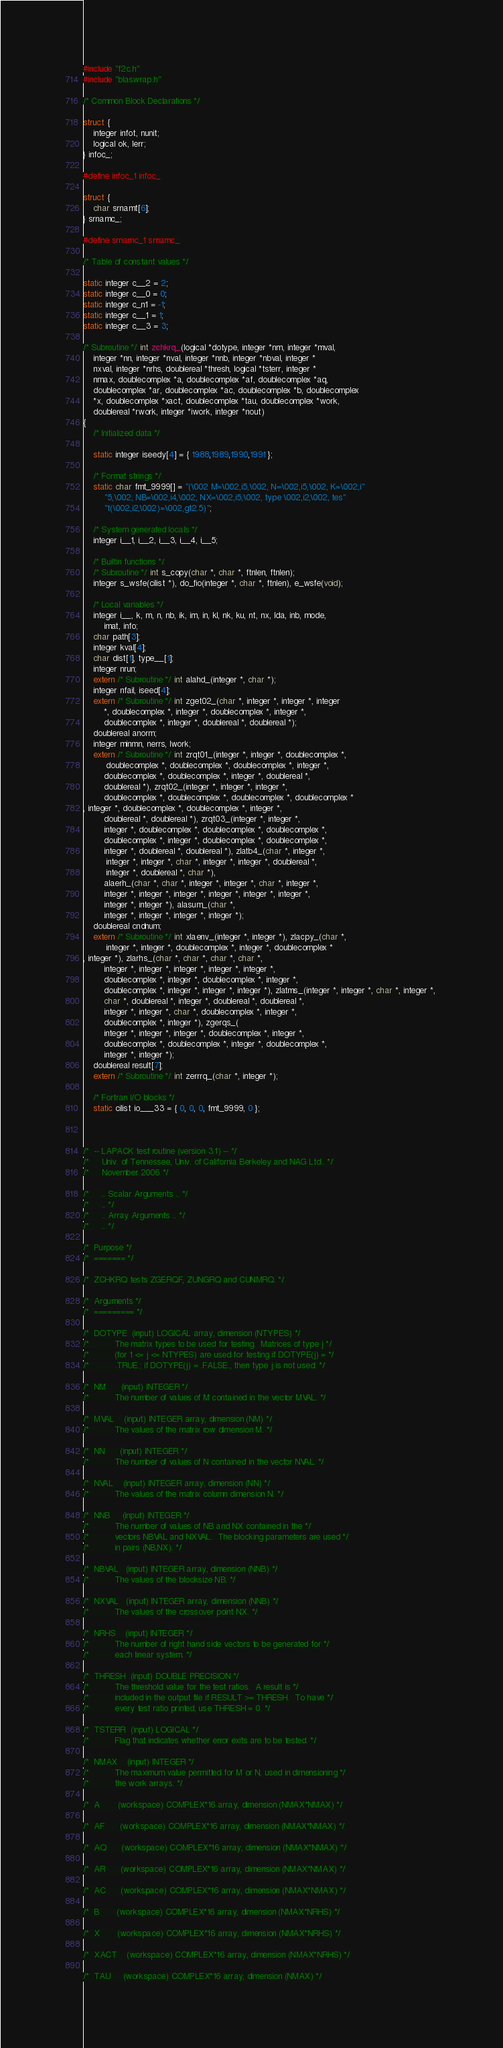Convert code to text. <code><loc_0><loc_0><loc_500><loc_500><_C_>#include "f2c.h"
#include "blaswrap.h"

/* Common Block Declarations */

struct {
    integer infot, nunit;
    logical ok, lerr;
} infoc_;

#define infoc_1 infoc_

struct {
    char srnamt[6];
} srnamc_;

#define srnamc_1 srnamc_

/* Table of constant values */

static integer c__2 = 2;
static integer c__0 = 0;
static integer c_n1 = -1;
static integer c__1 = 1;
static integer c__3 = 3;

/* Subroutine */ int zchkrq_(logical *dotype, integer *nm, integer *mval, 
	integer *nn, integer *nval, integer *nnb, integer *nbval, integer *
	nxval, integer *nrhs, doublereal *thresh, logical *tsterr, integer *
	nmax, doublecomplex *a, doublecomplex *af, doublecomplex *aq, 
	doublecomplex *ar, doublecomplex *ac, doublecomplex *b, doublecomplex 
	*x, doublecomplex *xact, doublecomplex *tau, doublecomplex *work, 
	doublereal *rwork, integer *iwork, integer *nout)
{
    /* Initialized data */

    static integer iseedy[4] = { 1988,1989,1990,1991 };

    /* Format strings */
    static char fmt_9999[] = "(\002 M=\002,i5,\002, N=\002,i5,\002, K=\002,i"
	    "5,\002, NB=\002,i4,\002, NX=\002,i5,\002, type \002,i2,\002, tes"
	    "t(\002,i2,\002)=\002,g12.5)";

    /* System generated locals */
    integer i__1, i__2, i__3, i__4, i__5;

    /* Builtin functions */
    /* Subroutine */ int s_copy(char *, char *, ftnlen, ftnlen);
    integer s_wsfe(cilist *), do_fio(integer *, char *, ftnlen), e_wsfe(void);

    /* Local variables */
    integer i__, k, m, n, nb, ik, im, in, kl, nk, ku, nt, nx, lda, inb, mode, 
	    imat, info;
    char path[3];
    integer kval[4];
    char dist[1], type__[1];
    integer nrun;
    extern /* Subroutine */ int alahd_(integer *, char *);
    integer nfail, iseed[4];
    extern /* Subroutine */ int zget02_(char *, integer *, integer *, integer 
	    *, doublecomplex *, integer *, doublecomplex *, integer *, 
	    doublecomplex *, integer *, doublereal *, doublereal *);
    doublereal anorm;
    integer minmn, nerrs, lwork;
    extern /* Subroutine */ int zrqt01_(integer *, integer *, doublecomplex *, 
	     doublecomplex *, doublecomplex *, doublecomplex *, integer *, 
	    doublecomplex *, doublecomplex *, integer *, doublereal *, 
	    doublereal *), zrqt02_(integer *, integer *, integer *, 
	    doublecomplex *, doublecomplex *, doublecomplex *, doublecomplex *
, integer *, doublecomplex *, doublecomplex *, integer *, 
	    doublereal *, doublereal *), zrqt03_(integer *, integer *, 
	    integer *, doublecomplex *, doublecomplex *, doublecomplex *, 
	    doublecomplex *, integer *, doublecomplex *, doublecomplex *, 
	    integer *, doublereal *, doublereal *), zlatb4_(char *, integer *, 
	     integer *, integer *, char *, integer *, integer *, doublereal *, 
	     integer *, doublereal *, char *), 
	    alaerh_(char *, char *, integer *, integer *, char *, integer *, 
	    integer *, integer *, integer *, integer *, integer *, integer *, 
	    integer *, integer *), alasum_(char *, 
	    integer *, integer *, integer *, integer *);
    doublereal cndnum;
    extern /* Subroutine */ int xlaenv_(integer *, integer *), zlacpy_(char *, 
	     integer *, integer *, doublecomplex *, integer *, doublecomplex *
, integer *), zlarhs_(char *, char *, char *, char *, 
	    integer *, integer *, integer *, integer *, integer *, 
	    doublecomplex *, integer *, doublecomplex *, integer *, 
	    doublecomplex *, integer *, integer *, integer *), zlatms_(integer *, integer *, char *, integer *, 
	    char *, doublereal *, integer *, doublereal *, doublereal *, 
	    integer *, integer *, char *, doublecomplex *, integer *, 
	    doublecomplex *, integer *), zgerqs_(
	    integer *, integer *, integer *, doublecomplex *, integer *, 
	    doublecomplex *, doublecomplex *, integer *, doublecomplex *, 
	    integer *, integer *);
    doublereal result[7];
    extern /* Subroutine */ int zerrrq_(char *, integer *);

    /* Fortran I/O blocks */
    static cilist io___33 = { 0, 0, 0, fmt_9999, 0 };



/*  -- LAPACK test routine (version 3.1) -- */
/*     Univ. of Tennessee, Univ. of California Berkeley and NAG Ltd.. */
/*     November 2006 */

/*     .. Scalar Arguments .. */
/*     .. */
/*     .. Array Arguments .. */
/*     .. */

/*  Purpose */
/*  ======= */

/*  ZCHKRQ tests ZGERQF, ZUNGRQ and CUNMRQ. */

/*  Arguments */
/*  ========= */

/*  DOTYPE  (input) LOGICAL array, dimension (NTYPES) */
/*          The matrix types to be used for testing.  Matrices of type j */
/*          (for 1 <= j <= NTYPES) are used for testing if DOTYPE(j) = */
/*          .TRUE.; if DOTYPE(j) = .FALSE., then type j is not used. */

/*  NM      (input) INTEGER */
/*          The number of values of M contained in the vector MVAL. */

/*  MVAL    (input) INTEGER array, dimension (NM) */
/*          The values of the matrix row dimension M. */

/*  NN      (input) INTEGER */
/*          The number of values of N contained in the vector NVAL. */

/*  NVAL    (input) INTEGER array, dimension (NN) */
/*          The values of the matrix column dimension N. */

/*  NNB     (input) INTEGER */
/*          The number of values of NB and NX contained in the */
/*          vectors NBVAL and NXVAL.  The blocking parameters are used */
/*          in pairs (NB,NX). */

/*  NBVAL   (input) INTEGER array, dimension (NNB) */
/*          The values of the blocksize NB. */

/*  NXVAL   (input) INTEGER array, dimension (NNB) */
/*          The values of the crossover point NX. */

/*  NRHS    (input) INTEGER */
/*          The number of right hand side vectors to be generated for */
/*          each linear system. */

/*  THRESH  (input) DOUBLE PRECISION */
/*          The threshold value for the test ratios.  A result is */
/*          included in the output file if RESULT >= THRESH.  To have */
/*          every test ratio printed, use THRESH = 0. */

/*  TSTERR  (input) LOGICAL */
/*          Flag that indicates whether error exits are to be tested. */

/*  NMAX    (input) INTEGER */
/*          The maximum value permitted for M or N, used in dimensioning */
/*          the work arrays. */

/*  A       (workspace) COMPLEX*16 array, dimension (NMAX*NMAX) */

/*  AF      (workspace) COMPLEX*16 array, dimension (NMAX*NMAX) */

/*  AQ      (workspace) COMPLEX*16 array, dimension (NMAX*NMAX) */

/*  AR      (workspace) COMPLEX*16 array, dimension (NMAX*NMAX) */

/*  AC      (workspace) COMPLEX*16 array, dimension (NMAX*NMAX) */

/*  B       (workspace) COMPLEX*16 array, dimension (NMAX*NRHS) */

/*  X       (workspace) COMPLEX*16 array, dimension (NMAX*NRHS) */

/*  XACT    (workspace) COMPLEX*16 array, dimension (NMAX*NRHS) */

/*  TAU     (workspace) COMPLEX*16 array, dimension (NMAX) */
</code> 